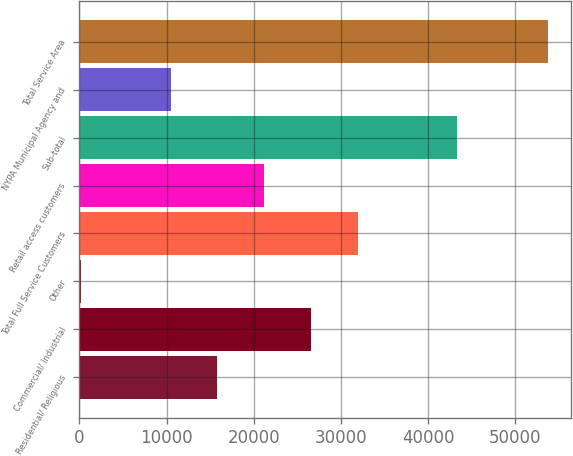<chart> <loc_0><loc_0><loc_500><loc_500><bar_chart><fcel>Residential/ Religious<fcel>Commercial/ Industrial<fcel>Other<fcel>Total Full Service Customers<fcel>Retail access customers<fcel>Sub-total<fcel>NYPA Municipal Agency and<fcel>Total Service Area<nl><fcel>15828.1<fcel>26544.3<fcel>154<fcel>31902.4<fcel>21186.2<fcel>43265<fcel>10470<fcel>53735<nl></chart> 